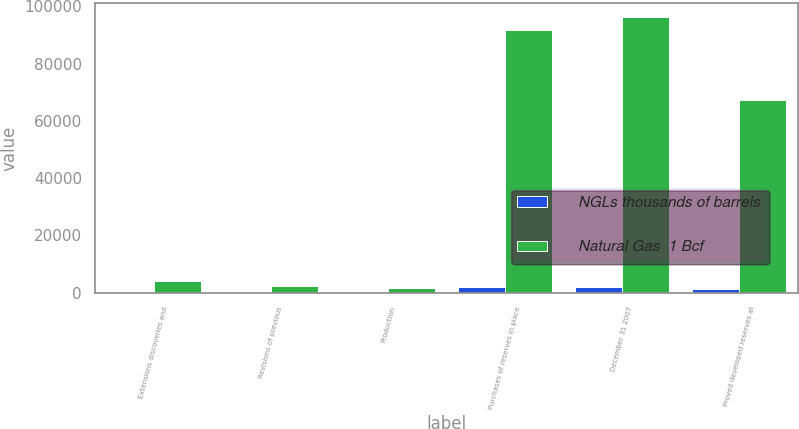<chart> <loc_0><loc_0><loc_500><loc_500><stacked_bar_chart><ecel><fcel>Extensions discoveries and<fcel>Revisions of previous<fcel>Production<fcel>Purchases of reserves in place<fcel>December 31 2007<fcel>Proved developed reserves at<nl><fcel>NGLs thousands of barrels<fcel>62<fcel>51<fcel>34<fcel>1919<fcel>1896<fcel>1394<nl><fcel>Natural Gas  1 Bcf<fcel>3877<fcel>2164<fcel>1627<fcel>91868<fcel>96282<fcel>67371<nl></chart> 